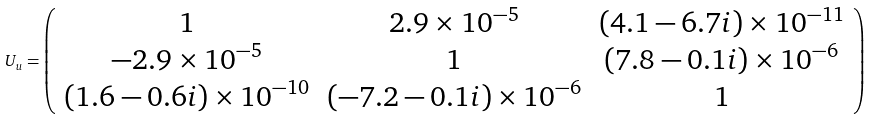<formula> <loc_0><loc_0><loc_500><loc_500>U _ { u } = \left ( \begin{array} { c c c } 1 & 2 . 9 \times 1 0 ^ { - 5 } & ( 4 . 1 - 6 . 7 i ) \times 1 0 ^ { - 1 1 } \\ - 2 . 9 \times 1 0 ^ { - 5 } & 1 & ( 7 . 8 - 0 . 1 i ) \times 1 0 ^ { - 6 } \\ ( 1 . 6 - 0 . 6 i ) \times 1 0 ^ { - 1 0 } & ( - 7 . 2 - 0 . 1 i ) \times 1 0 ^ { - 6 } & 1 \end{array} \right )</formula> 